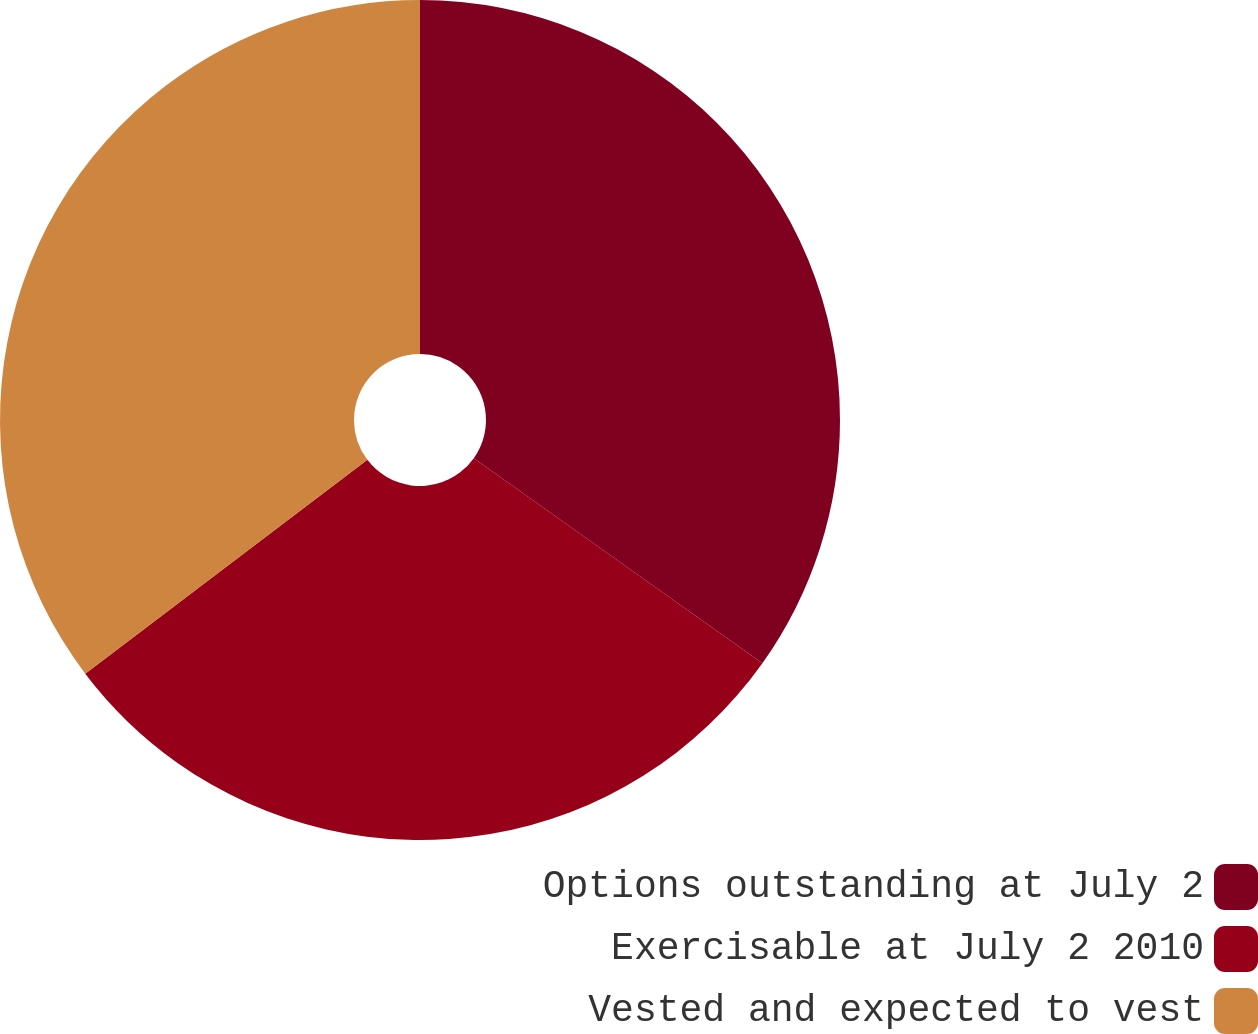<chart> <loc_0><loc_0><loc_500><loc_500><pie_chart><fcel>Options outstanding at July 2<fcel>Exercisable at July 2 2010<fcel>Vested and expected to vest<nl><fcel>34.83%<fcel>29.85%<fcel>35.32%<nl></chart> 